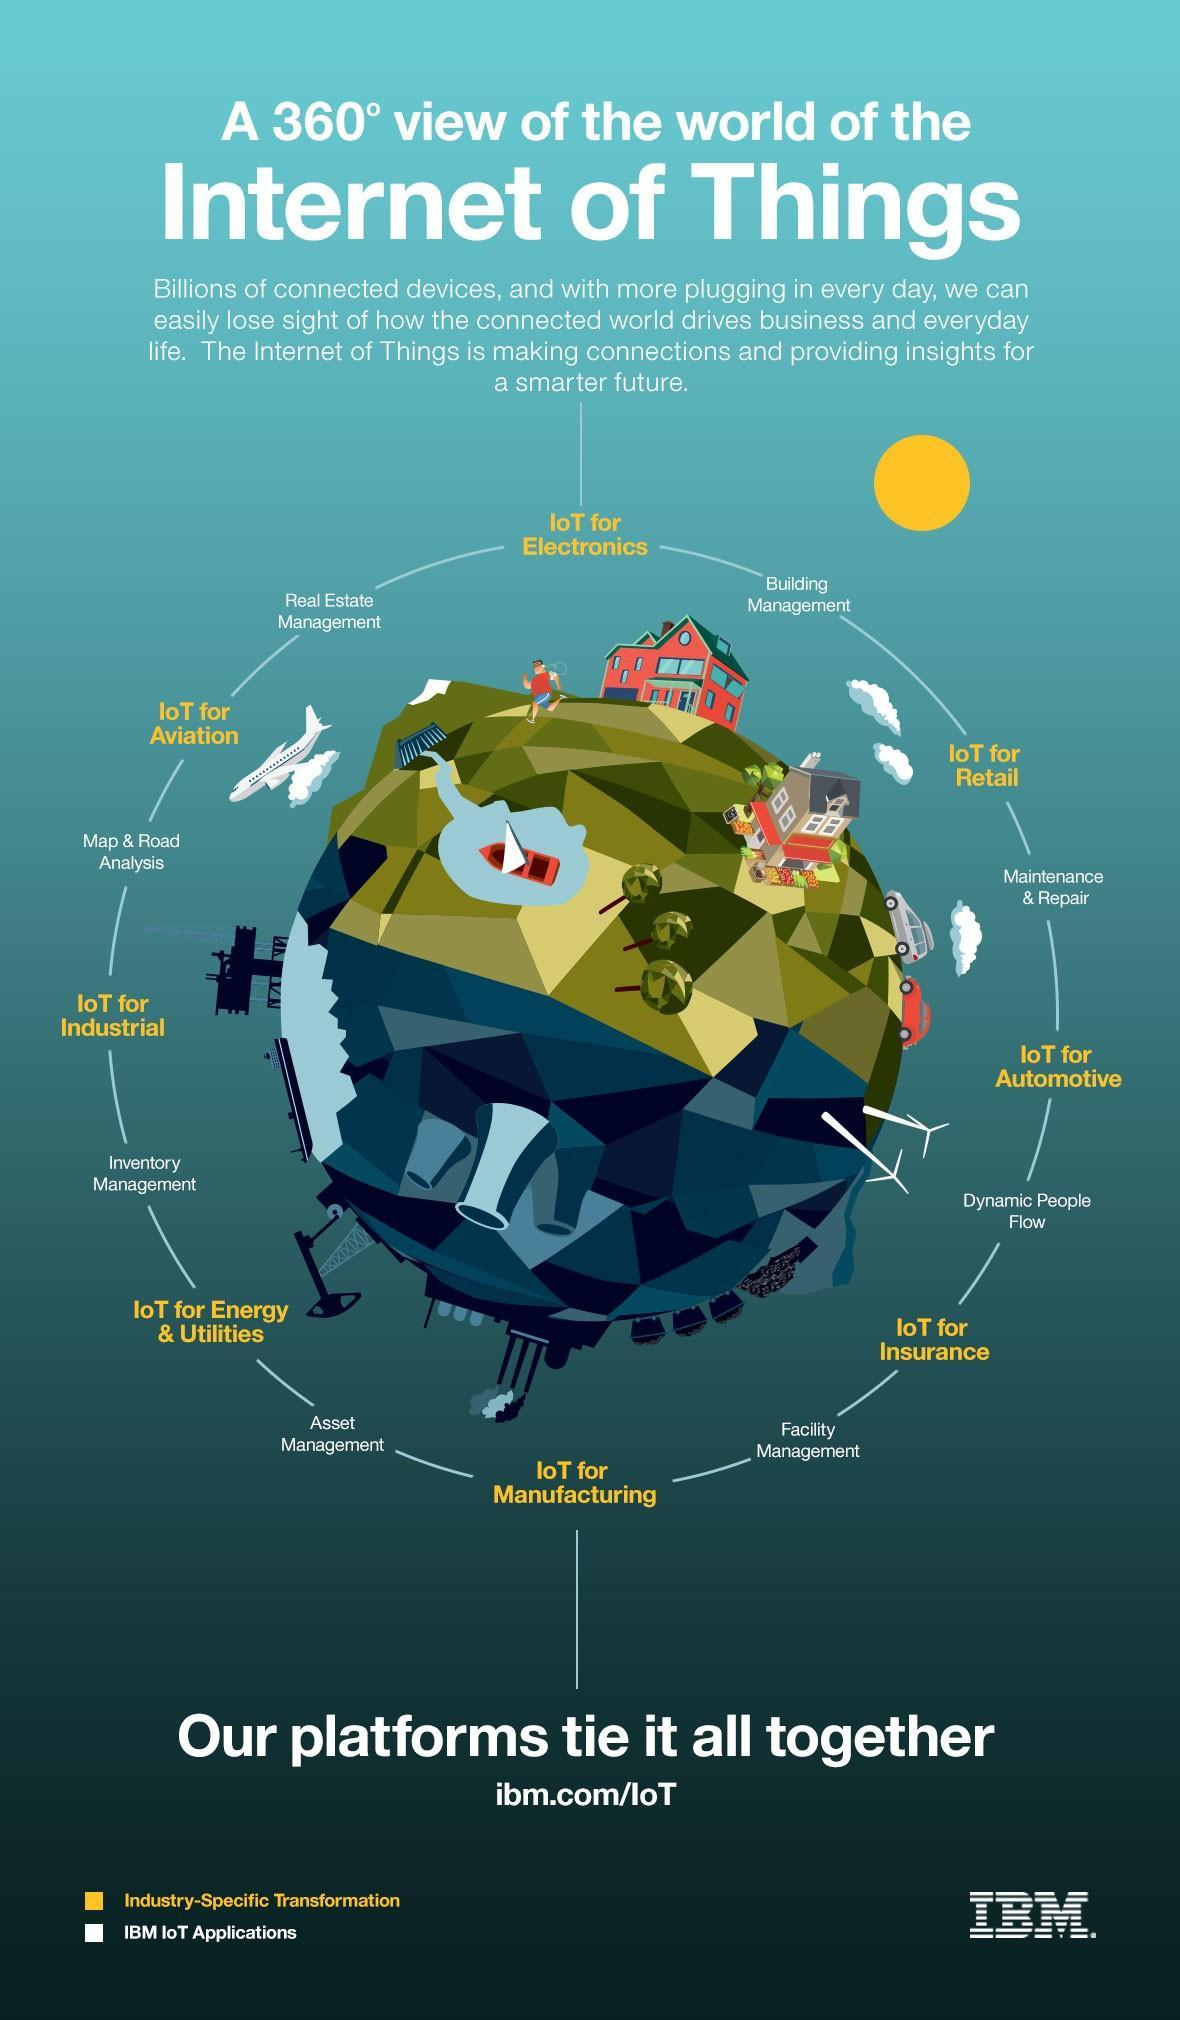How many branches or connections does Internet of Things have ?
Answer the question with a short phrase. 8 